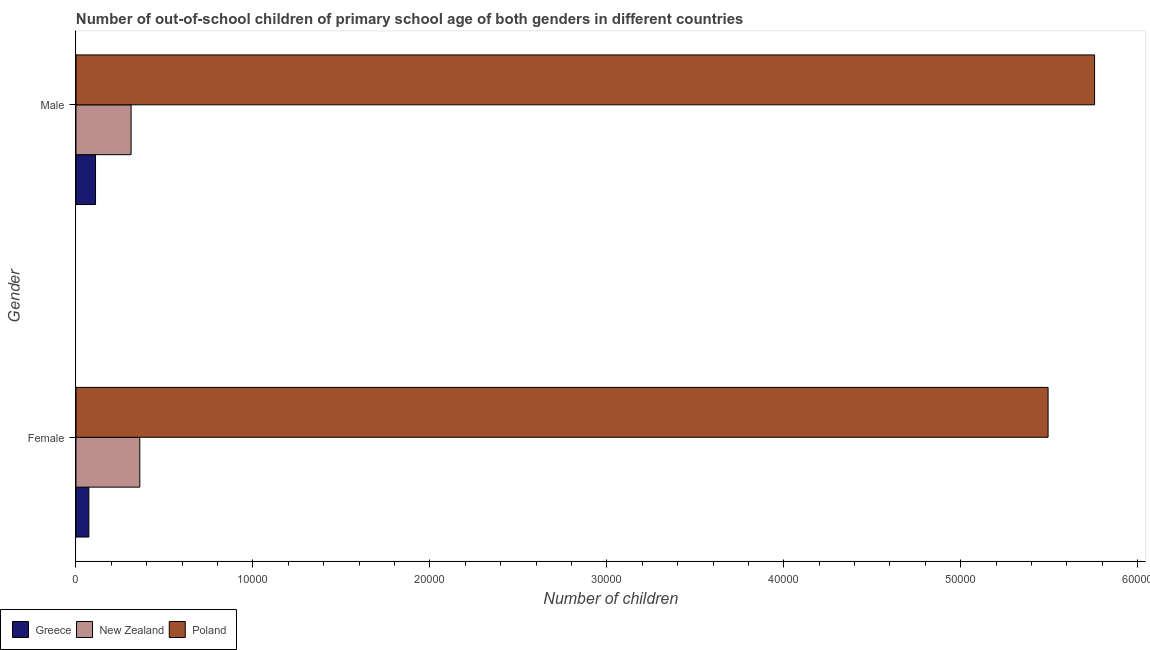How many groups of bars are there?
Make the answer very short. 2. Are the number of bars per tick equal to the number of legend labels?
Offer a terse response. Yes. How many bars are there on the 2nd tick from the top?
Provide a short and direct response. 3. How many bars are there on the 1st tick from the bottom?
Your answer should be very brief. 3. What is the label of the 1st group of bars from the top?
Your answer should be very brief. Male. What is the number of female out-of-school students in Greece?
Ensure brevity in your answer.  728. Across all countries, what is the maximum number of female out-of-school students?
Offer a terse response. 5.49e+04. Across all countries, what is the minimum number of male out-of-school students?
Your response must be concise. 1104. In which country was the number of female out-of-school students minimum?
Provide a succinct answer. Greece. What is the total number of male out-of-school students in the graph?
Provide a succinct answer. 6.18e+04. What is the difference between the number of female out-of-school students in New Zealand and that in Greece?
Offer a terse response. 2879. What is the difference between the number of female out-of-school students in Poland and the number of male out-of-school students in Greece?
Give a very brief answer. 5.38e+04. What is the average number of female out-of-school students per country?
Keep it short and to the point. 1.98e+04. What is the difference between the number of female out-of-school students and number of male out-of-school students in Poland?
Your response must be concise. -2627. In how many countries, is the number of male out-of-school students greater than 4000 ?
Keep it short and to the point. 1. What is the ratio of the number of male out-of-school students in New Zealand to that in Greece?
Provide a short and direct response. 2.82. What does the 1st bar from the top in Male represents?
Provide a succinct answer. Poland. What does the 1st bar from the bottom in Female represents?
Offer a terse response. Greece. How many countries are there in the graph?
Give a very brief answer. 3. What is the difference between two consecutive major ticks on the X-axis?
Offer a very short reply. 10000. Does the graph contain any zero values?
Your answer should be very brief. No. Does the graph contain grids?
Your answer should be very brief. No. How are the legend labels stacked?
Offer a very short reply. Horizontal. What is the title of the graph?
Give a very brief answer. Number of out-of-school children of primary school age of both genders in different countries. Does "Hungary" appear as one of the legend labels in the graph?
Offer a very short reply. No. What is the label or title of the X-axis?
Provide a short and direct response. Number of children. What is the Number of children of Greece in Female?
Give a very brief answer. 728. What is the Number of children of New Zealand in Female?
Make the answer very short. 3607. What is the Number of children of Poland in Female?
Give a very brief answer. 5.49e+04. What is the Number of children of Greece in Male?
Your response must be concise. 1104. What is the Number of children in New Zealand in Male?
Offer a terse response. 3114. What is the Number of children of Poland in Male?
Provide a succinct answer. 5.76e+04. Across all Gender, what is the maximum Number of children of Greece?
Offer a terse response. 1104. Across all Gender, what is the maximum Number of children in New Zealand?
Provide a succinct answer. 3607. Across all Gender, what is the maximum Number of children in Poland?
Keep it short and to the point. 5.76e+04. Across all Gender, what is the minimum Number of children in Greece?
Provide a succinct answer. 728. Across all Gender, what is the minimum Number of children in New Zealand?
Provide a short and direct response. 3114. Across all Gender, what is the minimum Number of children of Poland?
Provide a succinct answer. 5.49e+04. What is the total Number of children in Greece in the graph?
Provide a short and direct response. 1832. What is the total Number of children of New Zealand in the graph?
Make the answer very short. 6721. What is the total Number of children of Poland in the graph?
Provide a short and direct response. 1.12e+05. What is the difference between the Number of children of Greece in Female and that in Male?
Give a very brief answer. -376. What is the difference between the Number of children of New Zealand in Female and that in Male?
Offer a terse response. 493. What is the difference between the Number of children of Poland in Female and that in Male?
Keep it short and to the point. -2627. What is the difference between the Number of children in Greece in Female and the Number of children in New Zealand in Male?
Offer a very short reply. -2386. What is the difference between the Number of children of Greece in Female and the Number of children of Poland in Male?
Give a very brief answer. -5.68e+04. What is the difference between the Number of children in New Zealand in Female and the Number of children in Poland in Male?
Make the answer very short. -5.40e+04. What is the average Number of children in Greece per Gender?
Provide a succinct answer. 916. What is the average Number of children in New Zealand per Gender?
Give a very brief answer. 3360.5. What is the average Number of children of Poland per Gender?
Provide a succinct answer. 5.62e+04. What is the difference between the Number of children in Greece and Number of children in New Zealand in Female?
Provide a succinct answer. -2879. What is the difference between the Number of children in Greece and Number of children in Poland in Female?
Keep it short and to the point. -5.42e+04. What is the difference between the Number of children of New Zealand and Number of children of Poland in Female?
Provide a short and direct response. -5.13e+04. What is the difference between the Number of children of Greece and Number of children of New Zealand in Male?
Give a very brief answer. -2010. What is the difference between the Number of children of Greece and Number of children of Poland in Male?
Make the answer very short. -5.65e+04. What is the difference between the Number of children of New Zealand and Number of children of Poland in Male?
Your answer should be compact. -5.44e+04. What is the ratio of the Number of children in Greece in Female to that in Male?
Give a very brief answer. 0.66. What is the ratio of the Number of children of New Zealand in Female to that in Male?
Your answer should be compact. 1.16. What is the ratio of the Number of children in Poland in Female to that in Male?
Give a very brief answer. 0.95. What is the difference between the highest and the second highest Number of children in Greece?
Provide a succinct answer. 376. What is the difference between the highest and the second highest Number of children in New Zealand?
Your answer should be compact. 493. What is the difference between the highest and the second highest Number of children of Poland?
Provide a short and direct response. 2627. What is the difference between the highest and the lowest Number of children of Greece?
Your response must be concise. 376. What is the difference between the highest and the lowest Number of children in New Zealand?
Offer a terse response. 493. What is the difference between the highest and the lowest Number of children in Poland?
Give a very brief answer. 2627. 